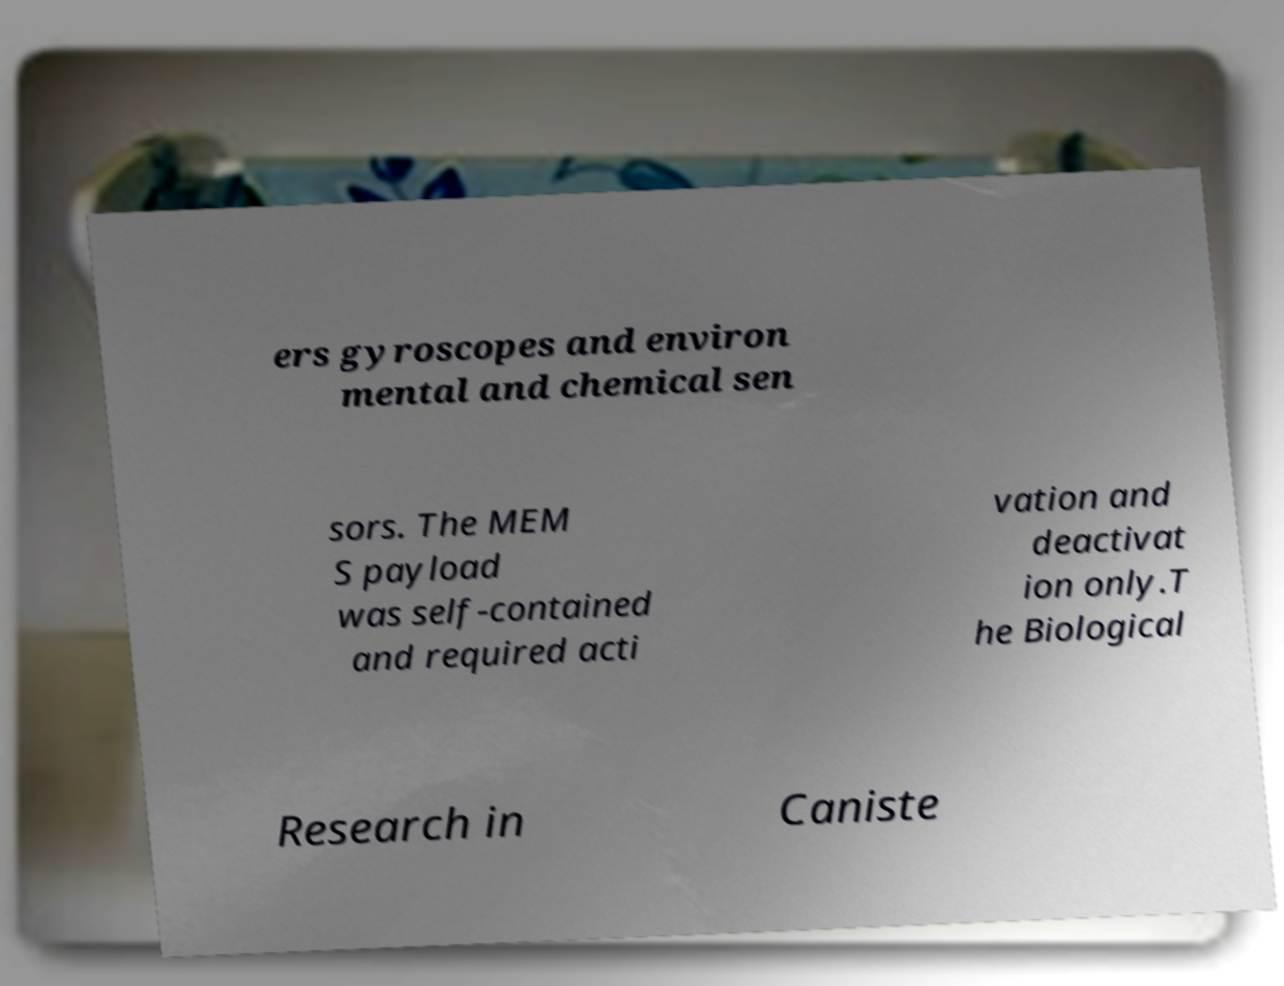Please identify and transcribe the text found in this image. ers gyroscopes and environ mental and chemical sen sors. The MEM S payload was self-contained and required acti vation and deactivat ion only.T he Biological Research in Caniste 